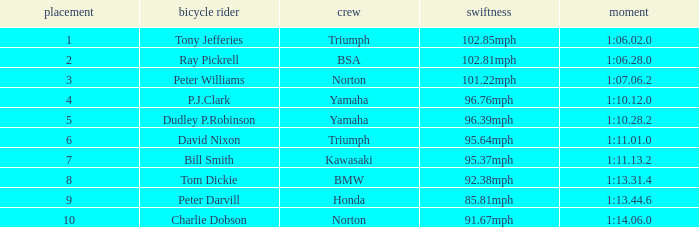Would you mind parsing the complete table? {'header': ['placement', 'bicycle rider', 'crew', 'swiftness', 'moment'], 'rows': [['1', 'Tony Jefferies', 'Triumph', '102.85mph', '1:06.02.0'], ['2', 'Ray Pickrell', 'BSA', '102.81mph', '1:06.28.0'], ['3', 'Peter Williams', 'Norton', '101.22mph', '1:07.06.2'], ['4', 'P.J.Clark', 'Yamaha', '96.76mph', '1:10.12.0'], ['5', 'Dudley P.Robinson', 'Yamaha', '96.39mph', '1:10.28.2'], ['6', 'David Nixon', 'Triumph', '95.64mph', '1:11.01.0'], ['7', 'Bill Smith', 'Kawasaki', '95.37mph', '1:11.13.2'], ['8', 'Tom Dickie', 'BMW', '92.38mph', '1:13.31.4'], ['9', 'Peter Darvill', 'Honda', '85.81mph', '1:13.44.6'], ['10', 'Charlie Dobson', 'Norton', '91.67mph', '1:14.06.0']]} How many Ranks have ray pickrell as a Rider? 1.0. 